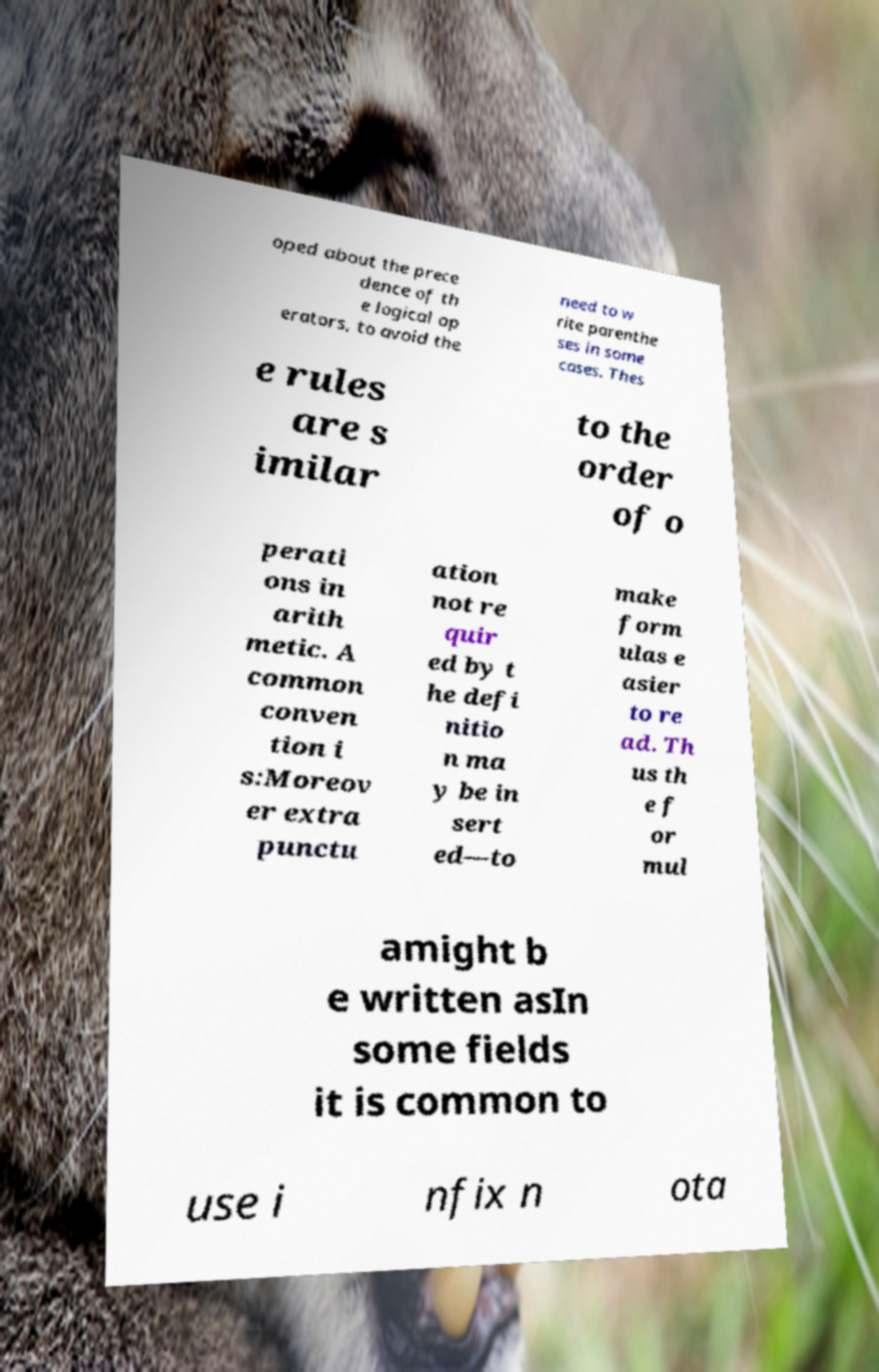For documentation purposes, I need the text within this image transcribed. Could you provide that? oped about the prece dence of th e logical op erators, to avoid the need to w rite parenthe ses in some cases. Thes e rules are s imilar to the order of o perati ons in arith metic. A common conven tion i s:Moreov er extra punctu ation not re quir ed by t he defi nitio n ma y be in sert ed—to make form ulas e asier to re ad. Th us th e f or mul amight b e written asIn some fields it is common to use i nfix n ota 